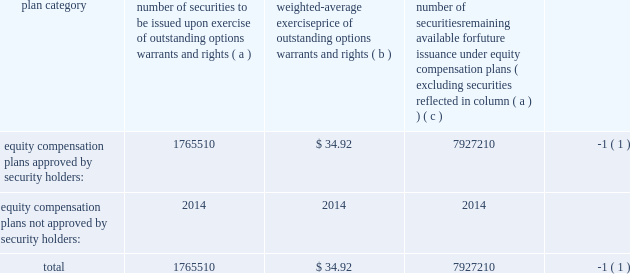Item 11 2014executive compensation we incorporate by reference in this item 11 the information relating to executive and director compensation contained under the headings 201cother information about the board and its committees , 201d 201ccompensation and other benefits 201d and 201creport of the compensation committee 201d from our proxy statement to be delivered in connection with our 2013 annual meeting of shareholders to be held on november 20 , 2013 .
Item 12 2014security ownership of certain beneficial owners and management and related stockholder matters we incorporate by reference in this item 12 the information relating to ownership of our common stock by certain persons contained under the headings 201ccommon stock ownership of management 201d and 201ccommon stock ownership by certain other persons 201d from our proxy statement to be delivered in connection with our 2013 annual meeting of shareholders to be held on november 20 , 2013 .
The table provides certain information as of may 31 , 2013 concerning the shares of the company 2019s common stock that may be issued under existing equity compensation plans .
For more information on these plans , see note 11 to notes to consolidated financial statements .
Plan category number of securities to be issued upon exercise of outstanding options , warrants and rights weighted- average exercise price of outstanding options , warrants and rights number of securities remaining available for future issuance under equity compensation plans ( excluding securities reflected in column ( a ) ) equity compensation plans approved by security holders : 1765510 $ 34.92 7927210 ( 1 ) equity compensation plans not approved by security holders : 2014 2014 2014 .
( 1 ) also includes shares of common stock available for issuance other than upon the exercise of an option , warrant or right under the global payments inc .
2000 long-term incentive plan , as amended and restated , the global payments inc .
Amended and restated 2005 incentive plan , amended and restated 2000 non- employee director stock option plan , global payments employee stock purchase plan and the global payments inc .
2011 incentive plan .
Item 13 2014certain relationships and related transactions , and director independence we incorporate by reference in this item 13 the information regarding certain relationships and related transactions between us and some of our affiliates and the independence of our board of directors contained under the headings 201ccertain relationships and related transactions 201d and 201cother information about the board and its committees 201d from our proxy statement to be delivered in connection with our 2013 annual meeting of shareholders to be held on november 20 , 2013 .
Item 14 2014principal accounting fees and services we incorporate by reference in this item 14 the information regarding principal accounting fees and services contained under the section ratification of the reappointment of auditors from our proxy statement to be delivered in connection with our 2013 annual meeting of shareholders to be held on november 20 , 2013. .
What is the total value of securities approved by security holders , ( in millions ) ? 
Computations: ((1765510 * 34.92) / 1000000)
Answer: 61.65161. 